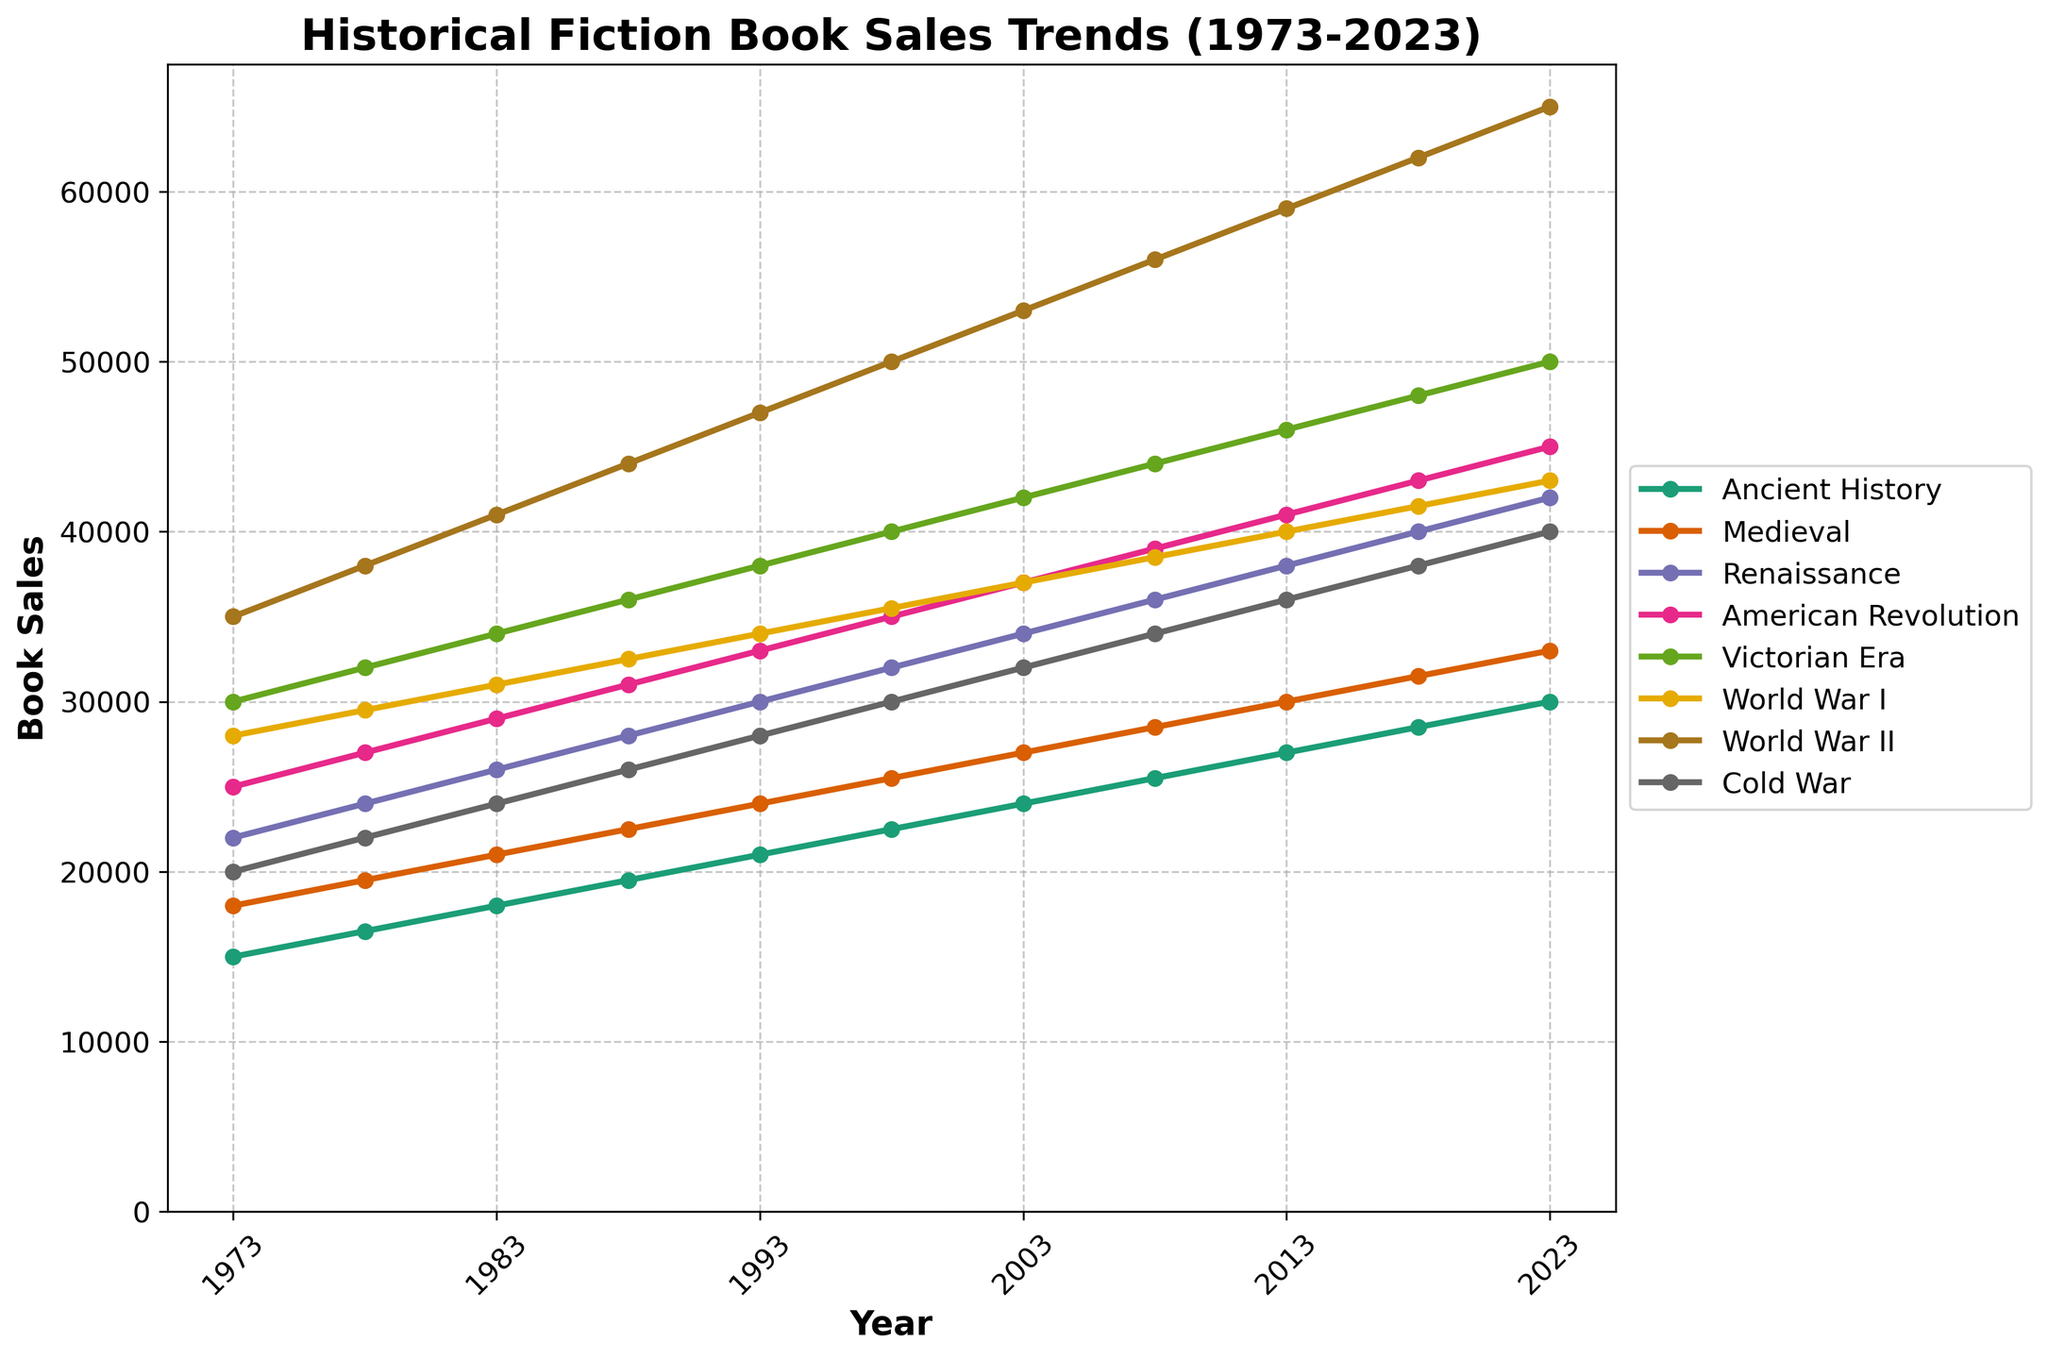what historical period had the highest book sales in 1973? Find the highest value on the vertical axis for the year 1973. The highest value is under the World War II category.
Answer: World War II Which historical period saw the largest increase in book sales from 1973 to 2023? Look at the difference between the 2023 and 1973 values for all periods. Calculate the increase: Ancient History (15000 to 30000) = 15000, Medieval (18000 to 33000) = 15000, Renaissance (22000 to 42000) = 20000, American Revolution (25000 to 45000) = 20000, Victorian Era (30000 to 50000) = 20000, World War I (28000 to 43000) = 15000, World War II (35000 to 65000) = 30000, Cold War (20000 to 40000) = 20000. World War II had the largest increase of 30000.
Answer: World War II What's the average book sales for the Renaissance and American Revolution periods in 2003? Sum the book sales for Renaissance (34000) and American Revolution (37000) in 2003 and divide by 2. (34000 + 37000) / 2 = 35500.
Answer: 35500 Which two historical periods had equal book sales in any year? Check all years for matching values across periods. In 1978, the book sales for Ancient History and Medieval are both 16500.
Answer: Ancient History and Medieval (1978) How have book sales for the Cold War period changed from 1993 to 2003? Look at the values for the Cold War period in 1993 (28000) and 2003 (32000). The change is 32000 - 28000 = 4000.
Answer: Increased by 4000 From 1973 to 2023, which period's sales had a continuous upward trend without any dip? Examine the trend lines for all periods from 1973 to 2023. All lines rise continuously without dips, but World War II shows a steady and clear upward trend.
Answer: World War II In which year did the American Revolution period book sales equal the Victorian Era book sales? Compare the values for the American Revolution and Victorian Era across all years. In 1983, both periods had book sales of 29000.
Answer: 1983 